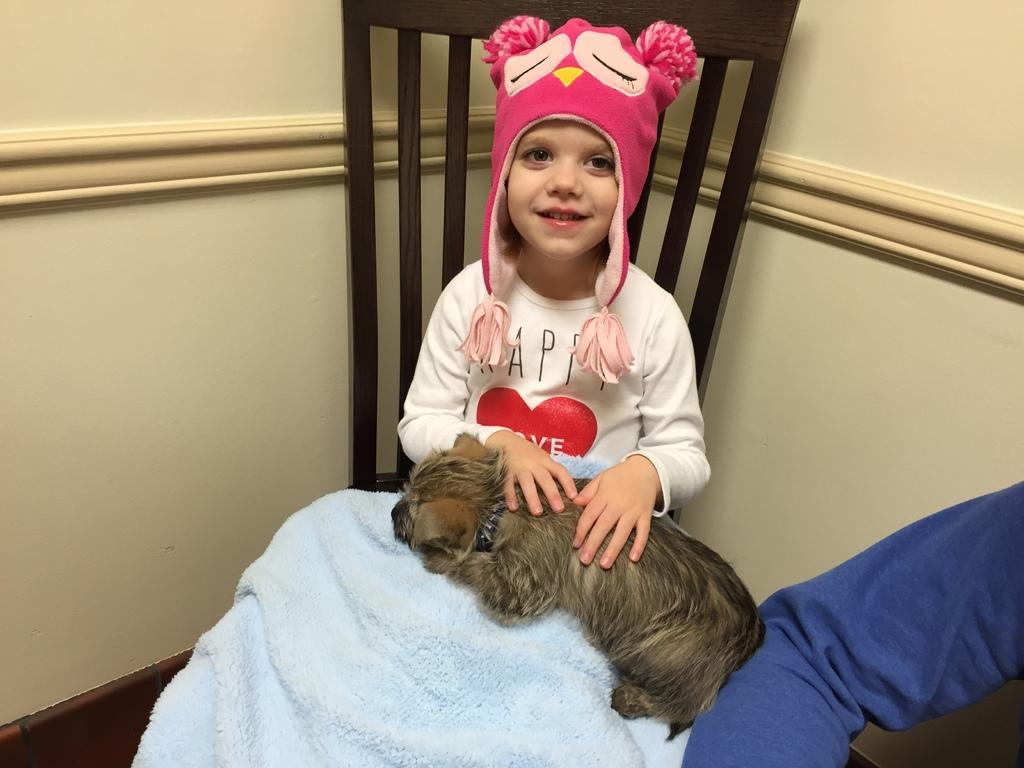What is the girl doing in the image? The girl is sitting on a chair in the image. What is on the girl's lap? There is a dog on the girl's lap. Whose hand is visible beside the girl? The hand of a person is visible beside the girl. What can be seen in the background of the image? There is a wall in the background of the image. How much peace is present in the image? The concept of "peace" is not directly observable in the image, as it is an abstract concept. However, the girl and the dog on her lap may convey a sense of calm or tranquility. 